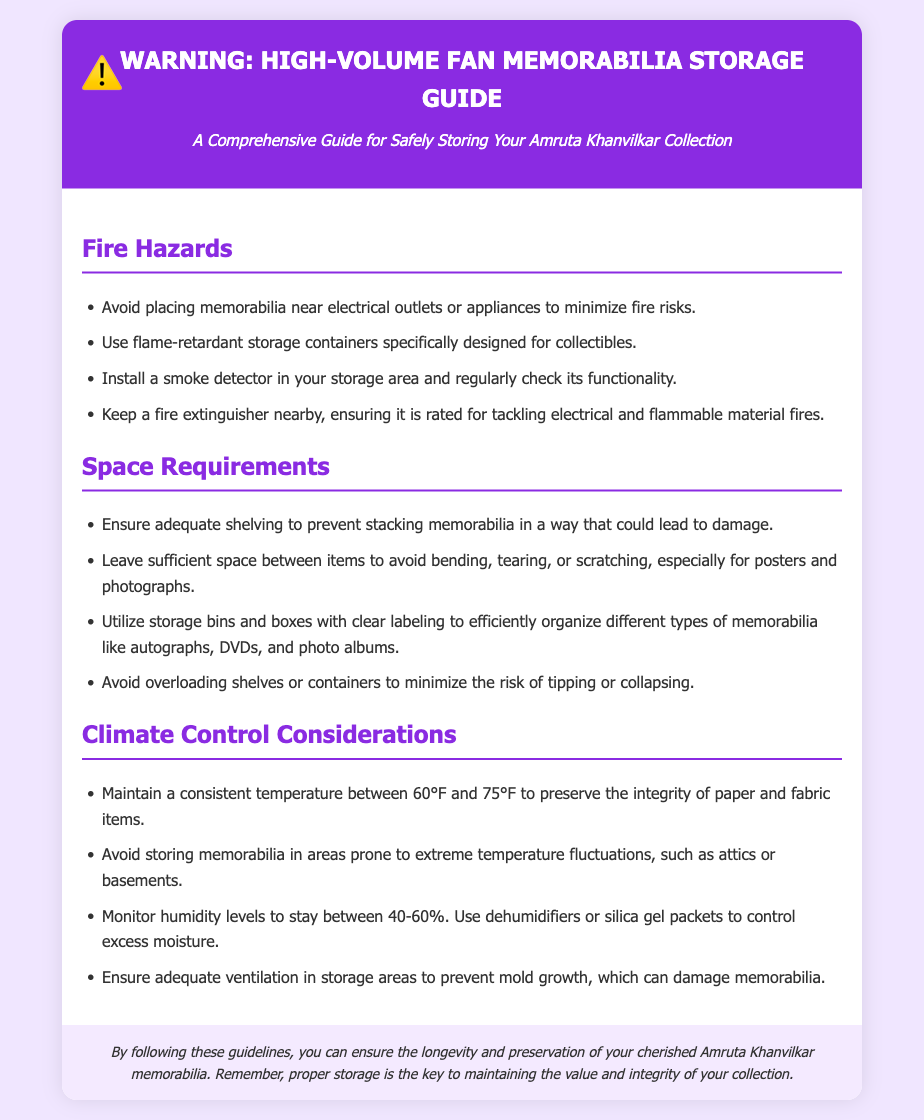What should you avoid placing near memorabilia? The document specifies that you should avoid placing memorabilia near electrical outlets or appliances to minimize fire risks.
Answer: Electrical outlets or appliances What temperature range is ideal for storing memorabilia? The document states that you should maintain a consistent temperature between 60°F and 75°F to preserve the integrity of paper and fabric items.
Answer: 60°F to 75°F What type of containers should be used for storage? It’s mentioned to use flame-retardant storage containers specifically designed for collectibles.
Answer: Flame-retardant storage containers How much space should you leave between items? The document advises leaving sufficient space between items to avoid bending, tearing, or scratching, especially for posters and photographs.
Answer: Sufficient space What humidity level is recommended for storing memorabilia? The document recommends monitoring humidity levels to stay between 40-60%.
Answer: 40-60% Why should you install a smoke detector in your storage area? The document specifies the importance of installing a smoke detector in your storage area and regularly checking its functionality for safety.
Answer: For safety What is one way to control excess moisture in storage? The document suggests using dehumidifiers or silica gel packets to control excess moisture.
Answer: Dehumidifiers or silica gel packets What may happen if you overload shelves? The document warns that overloading shelves or containers may lead to the risk of tipping or collapsing.
Answer: Tipping or collapsing 